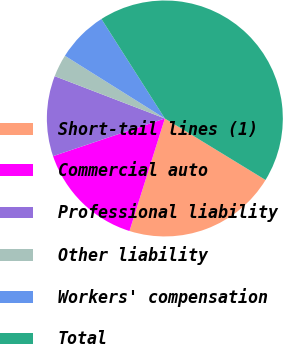Convert chart. <chart><loc_0><loc_0><loc_500><loc_500><pie_chart><fcel>Short-tail lines (1)<fcel>Commercial auto<fcel>Professional liability<fcel>Other liability<fcel>Workers' compensation<fcel>Total<nl><fcel>21.12%<fcel>14.98%<fcel>11.01%<fcel>3.08%<fcel>7.05%<fcel>42.76%<nl></chart> 